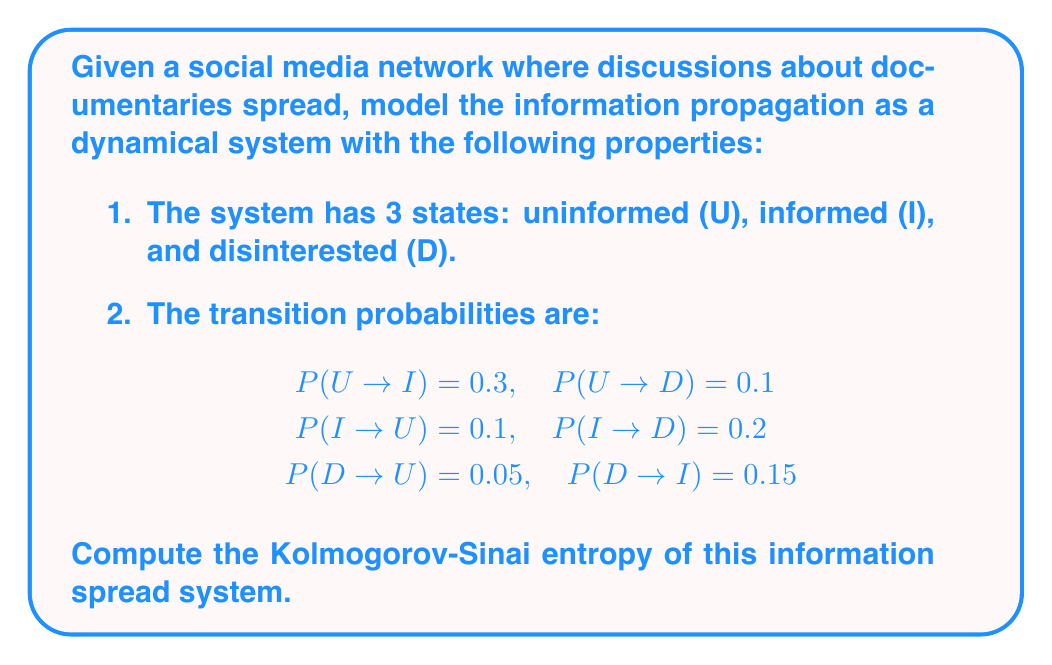Can you answer this question? To compute the Kolmogorov-Sinai entropy for this system, we'll follow these steps:

1. Construct the transition matrix:
   $$T = \begin{pmatrix}
   0.6 & 0.1 & 0.05 \\
   0.3 & 0.7 & 0.15 \\
   0.1 & 0.2 & 0.8
   \end{pmatrix}$$

2. Find the stationary distribution π by solving πT = π:
   Solving this system of equations yields:
   $$π = (0.1667, 0.5, 0.3333)$$

3. Calculate the Markov partition entropy:
   $$H = -\sum_{i,j} π_i T_{ij} \log T_{ij}$$

   $$\begin{align}
   H &= -[0.1667(0.6\log0.6 + 0.3\log0.3 + 0.1\log0.1) \\
     &+ 0.5(0.1\log0.1 + 0.7\log0.7 + 0.2\log0.2) \\
     &+ 0.3333(0.05\log0.05 + 0.15\log0.15 + 0.8\log0.8)]
   \end{align}$$

4. Evaluate the expression:
   $$H ≈ 0.8567$$

The Kolmogorov-Sinai entropy is equal to the Markov partition entropy for finite state Markov chains.
Answer: 0.8567 bits per iteration 